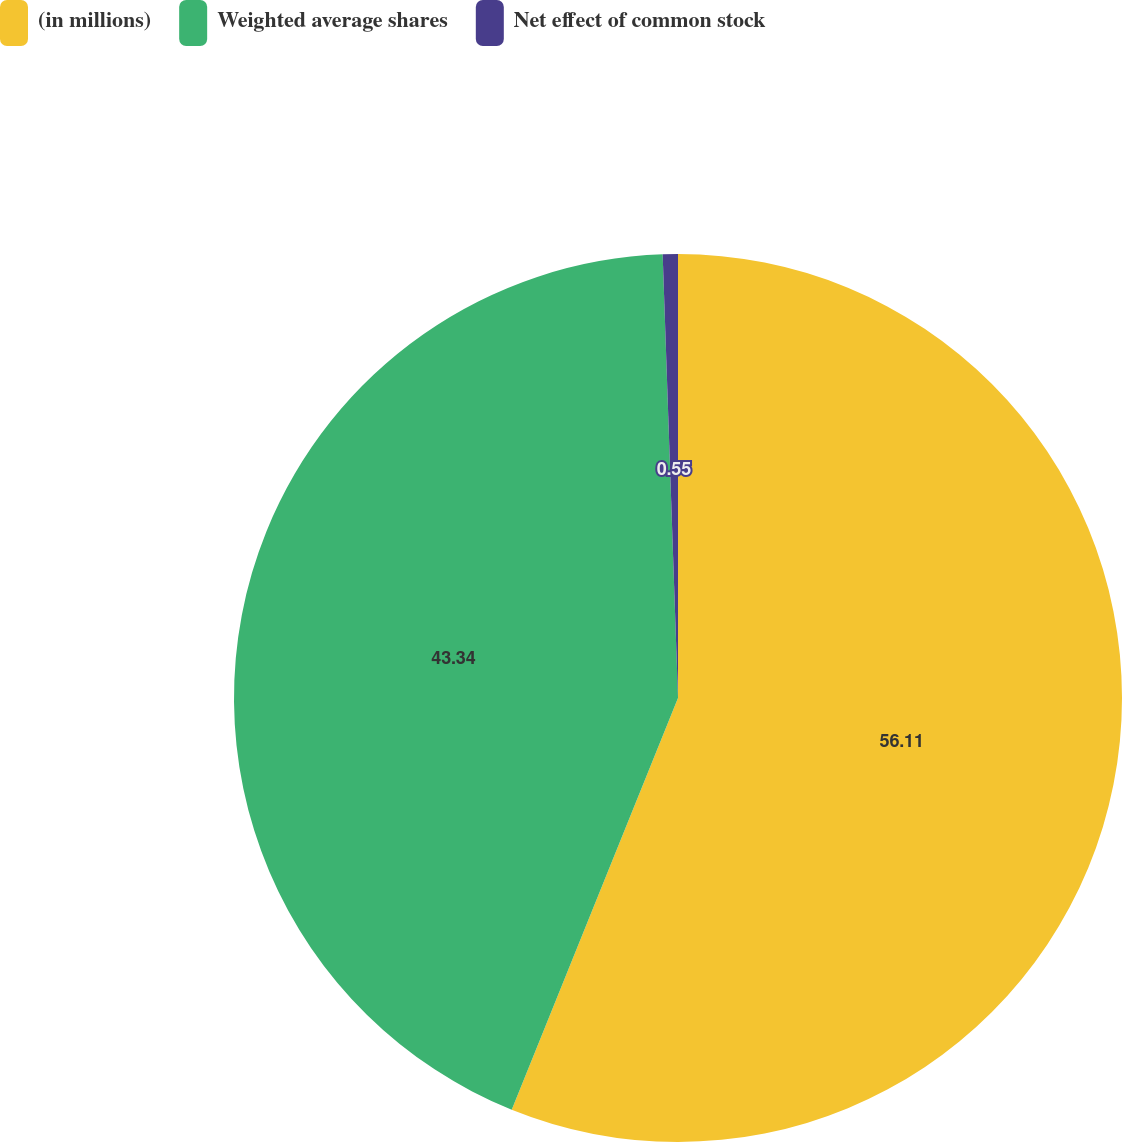Convert chart. <chart><loc_0><loc_0><loc_500><loc_500><pie_chart><fcel>(in millions)<fcel>Weighted average shares<fcel>Net effect of common stock<nl><fcel>56.11%<fcel>43.34%<fcel>0.55%<nl></chart> 